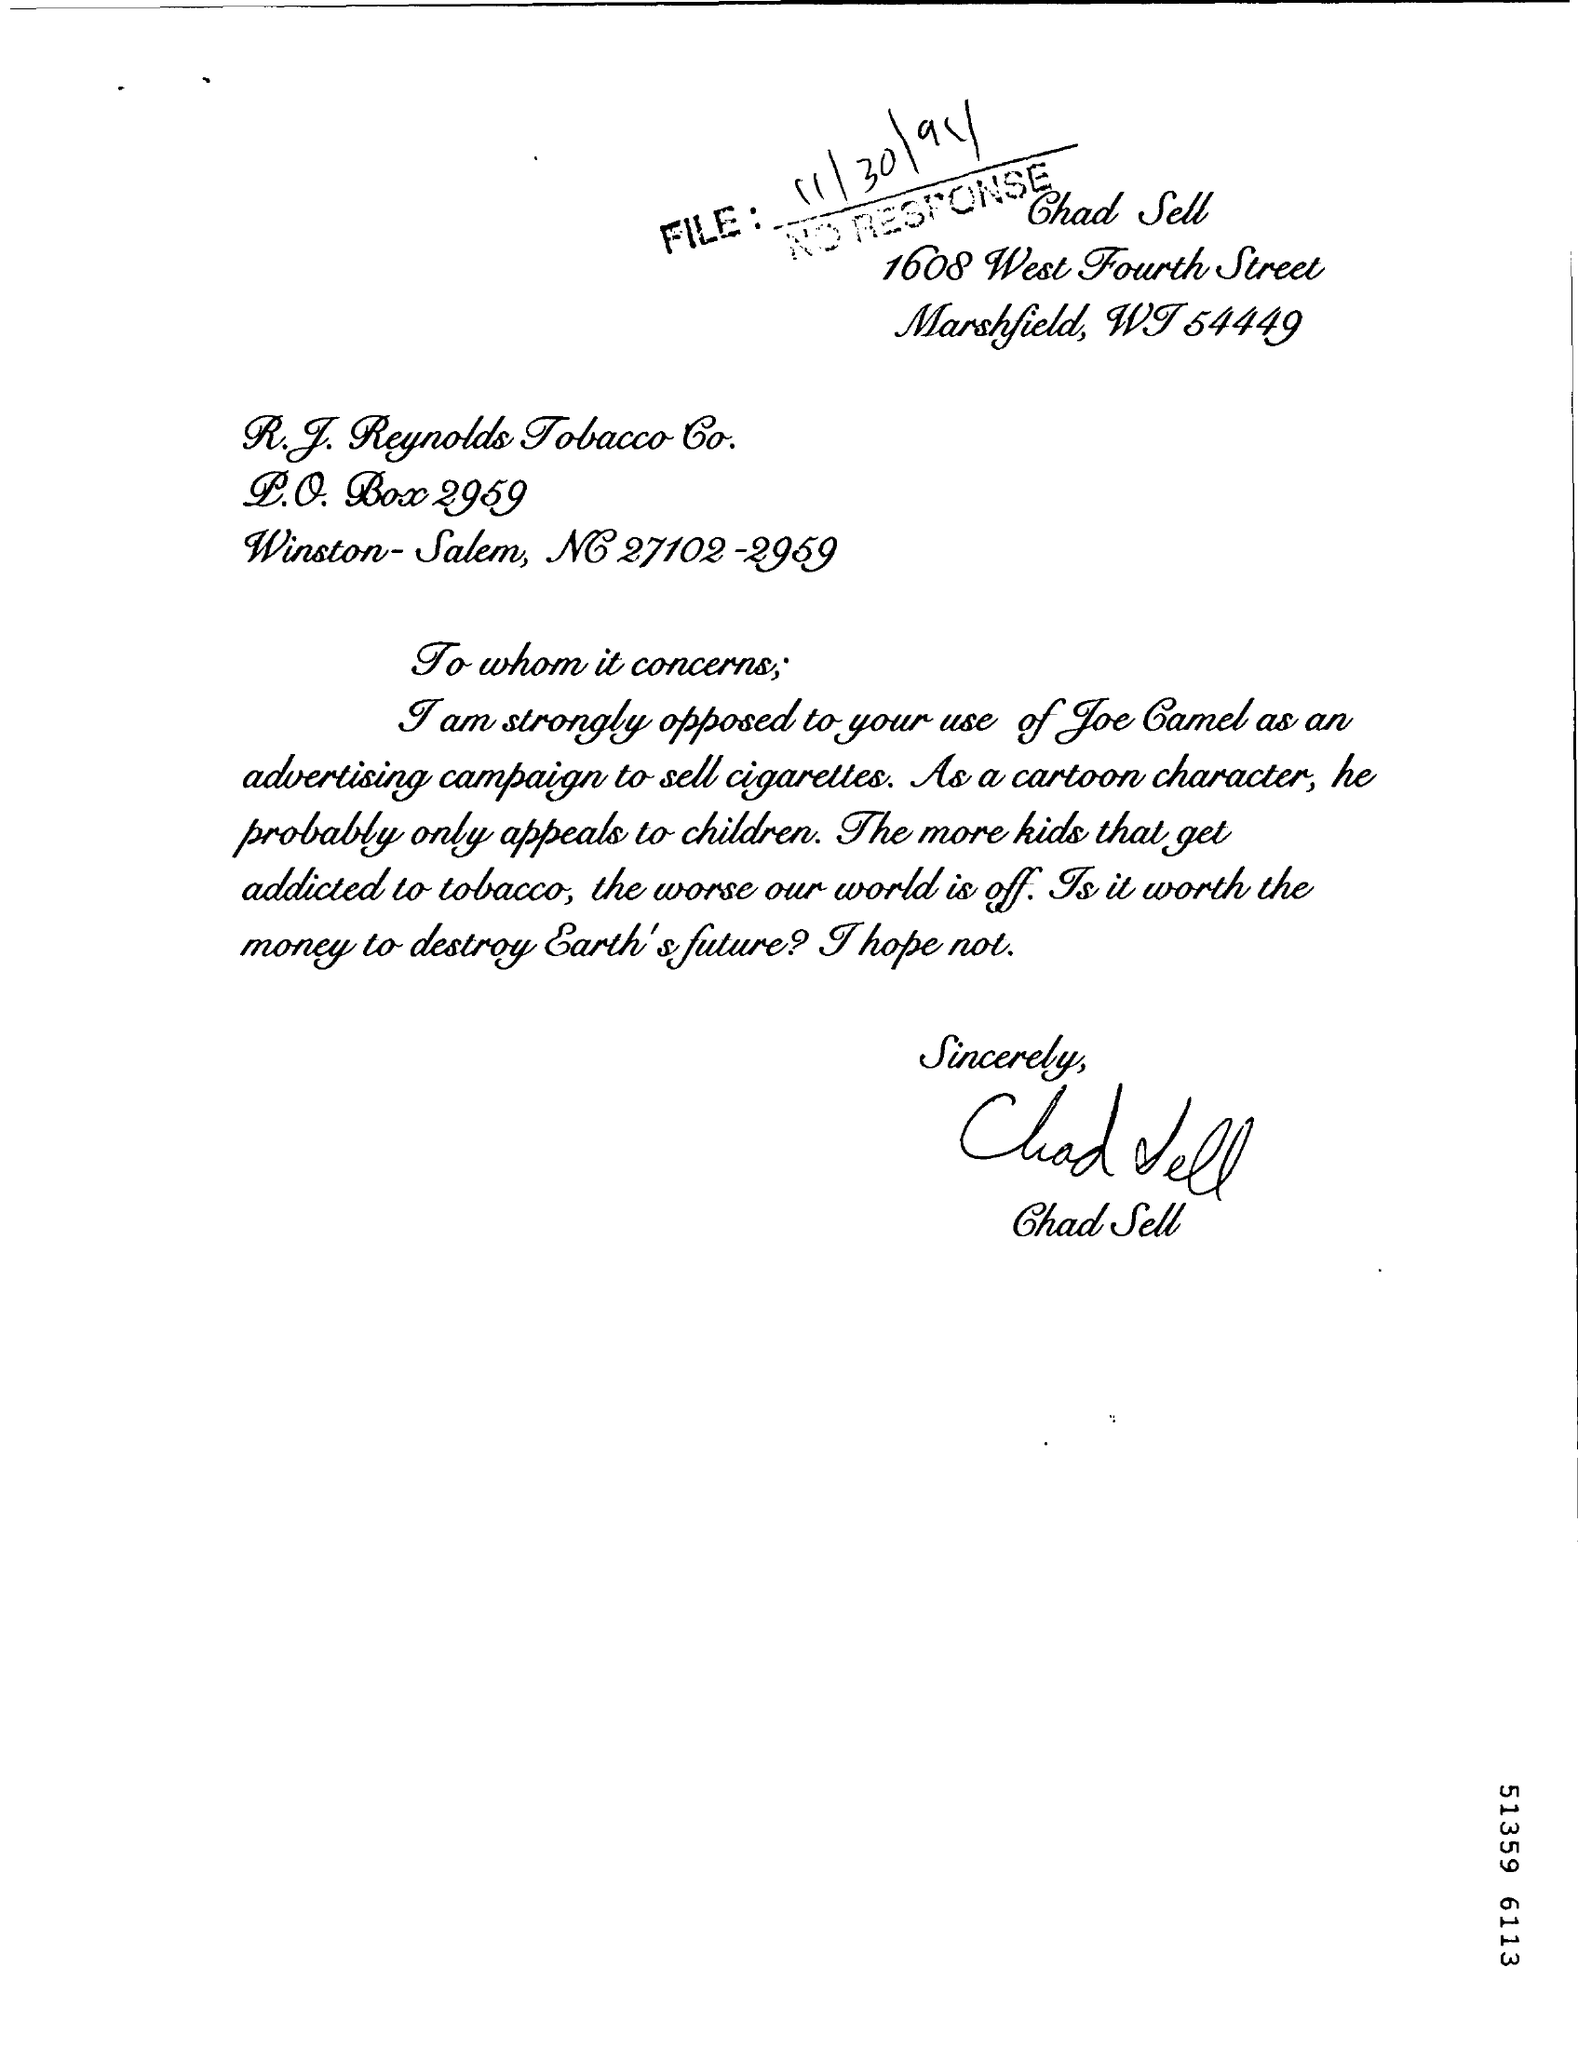Specify some key components in this picture. The author lives in Marshfield. The author of the letter is Chad Sell. 